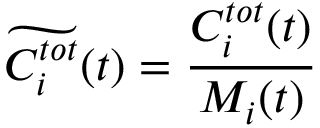Convert formula to latex. <formula><loc_0><loc_0><loc_500><loc_500>\widetilde { C _ { i } ^ { t o t } } ( t ) = \frac { C _ { i } ^ { t o t } ( t ) } { M _ { i } ( t ) }</formula> 